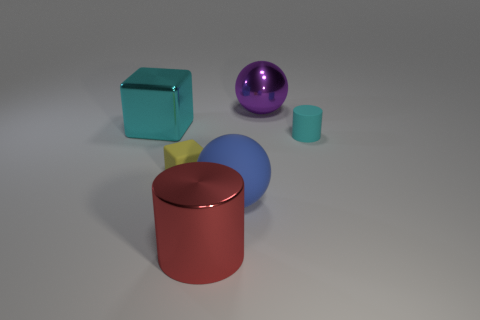How might you describe the arrangement of the objects? The arrangement of the objects on the surface appears intentional yet casual. Starting from the left, there's a dark teal cube followed by a shiny purple sphere. A small yellow star shape sits discreetly near the larger red cylinder which captures the viewer's attention due to its size and color. To the right, a blue sphere complements the scene, and finally, a small cyan cylinder balances the arrangement. The assortment of shapes, sizes, and colors creates a visually pleasing and balanced composition, suggesting a playful or experimental setting that could be indicative of a study in color, form, or material contrast. 